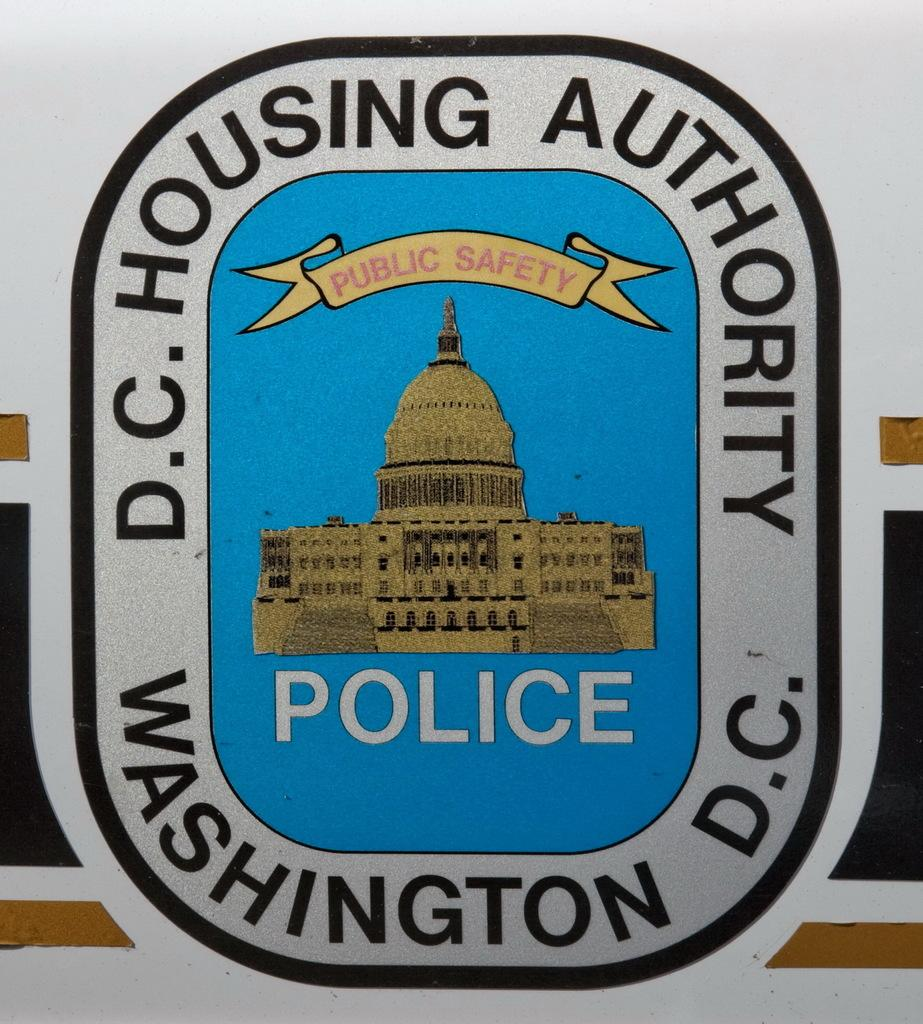<image>
Relay a brief, clear account of the picture shown. The logo for D.C. Housing Authority based in Washington D.C. 